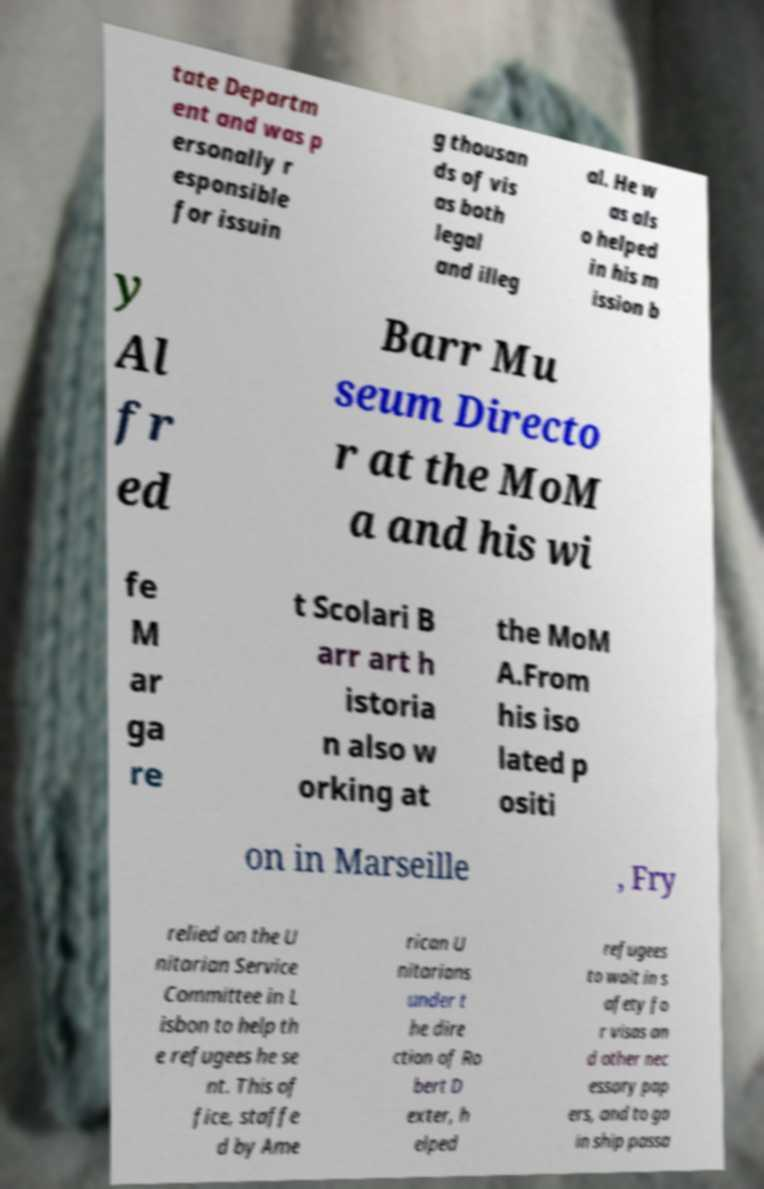Can you read and provide the text displayed in the image?This photo seems to have some interesting text. Can you extract and type it out for me? tate Departm ent and was p ersonally r esponsible for issuin g thousan ds of vis as both legal and illeg al. He w as als o helped in his m ission b y Al fr ed Barr Mu seum Directo r at the MoM a and his wi fe M ar ga re t Scolari B arr art h istoria n also w orking at the MoM A.From his iso lated p ositi on in Marseille , Fry relied on the U nitarian Service Committee in L isbon to help th e refugees he se nt. This of fice, staffe d by Ame rican U nitarians under t he dire ction of Ro bert D exter, h elped refugees to wait in s afety fo r visas an d other nec essary pap ers, and to ga in ship passa 